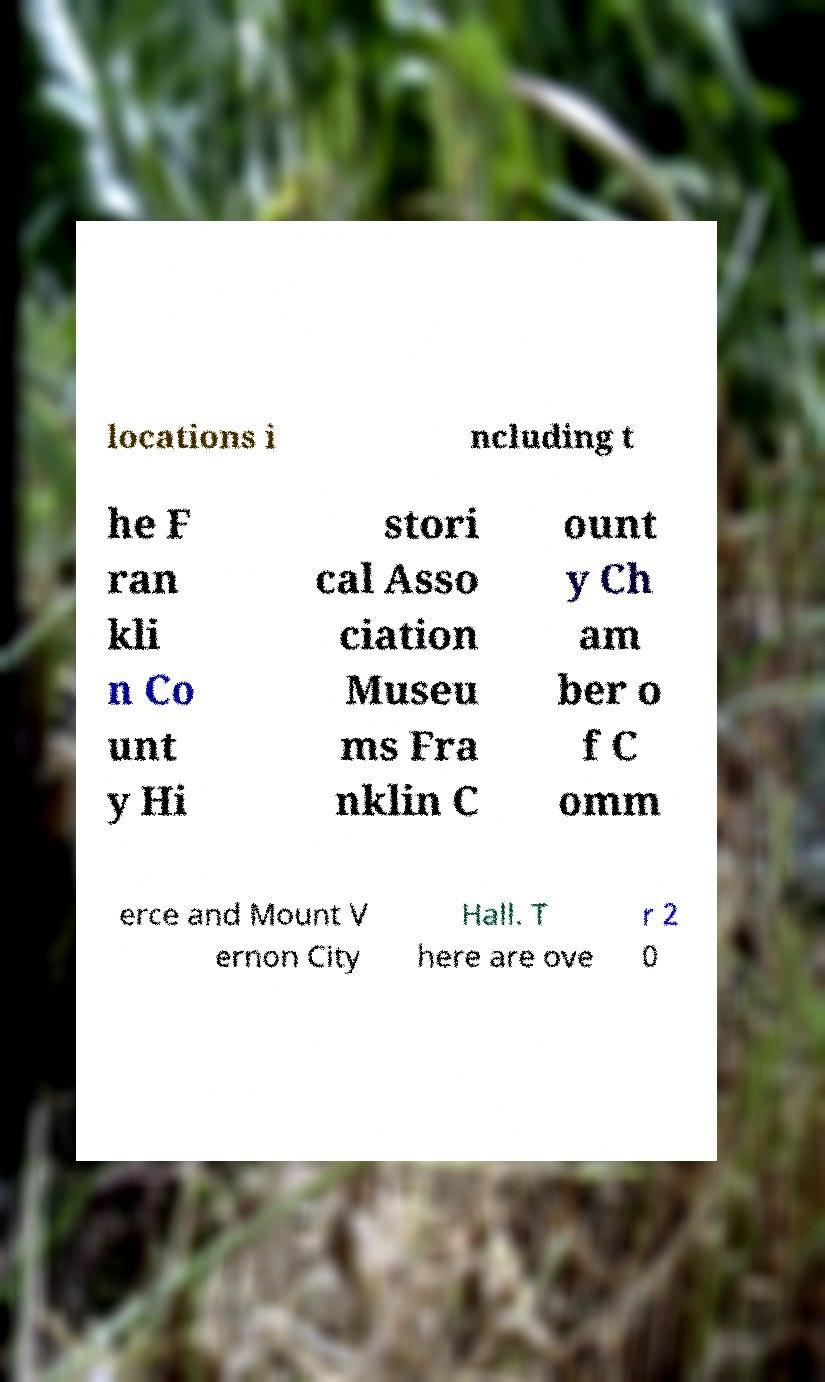What messages or text are displayed in this image? I need them in a readable, typed format. locations i ncluding t he F ran kli n Co unt y Hi stori cal Asso ciation Museu ms Fra nklin C ount y Ch am ber o f C omm erce and Mount V ernon City Hall. T here are ove r 2 0 